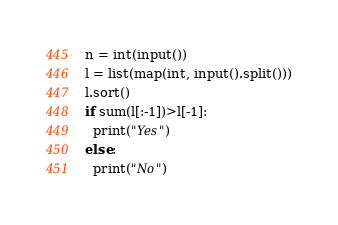<code> <loc_0><loc_0><loc_500><loc_500><_Python_>n = int(input())
l = list(map(int, input().split()))
l.sort()
if sum(l[:-1])>l[-1]:
  print("Yes")
else:
  print("No")</code> 